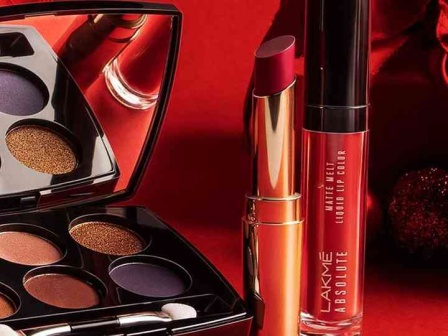Can you explain the different makeup looks one could achieve with these products? Absolutely! The eyeshadow palette offers a range of shades from vibrant purples to warm golds, ideal for creating bold, glamorous looks or a subtle, elegant appearance based on the combination. The gold lipstick can be used for a striking, luxurious lip focus, perfect for evening events. Meanwhile, the deep red liquid lip color provides a classic choice for a bold, assertive look suitable for professional or casual settings. Blending these products allows for versatile makeup applications, from everyday looks to special occasions. 